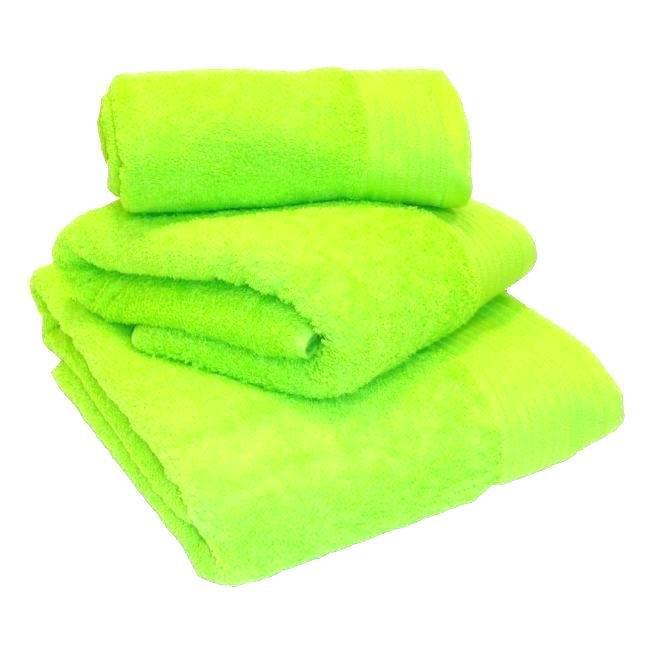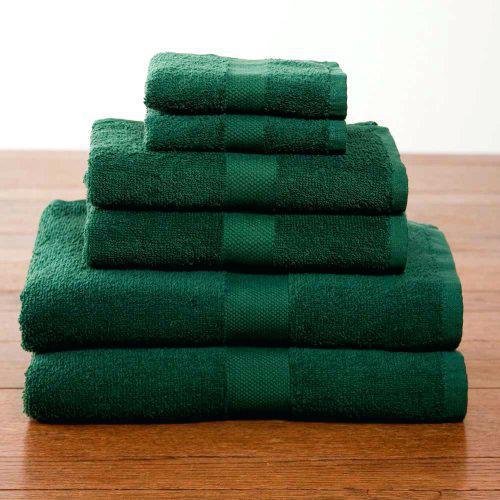The first image is the image on the left, the second image is the image on the right. Evaluate the accuracy of this statement regarding the images: "In one image there are six green towels.". Is it true? Answer yes or no. Yes. The first image is the image on the left, the second image is the image on the right. For the images displayed, is the sentence "There are exactly six towels in the right image." factually correct? Answer yes or no. Yes. 